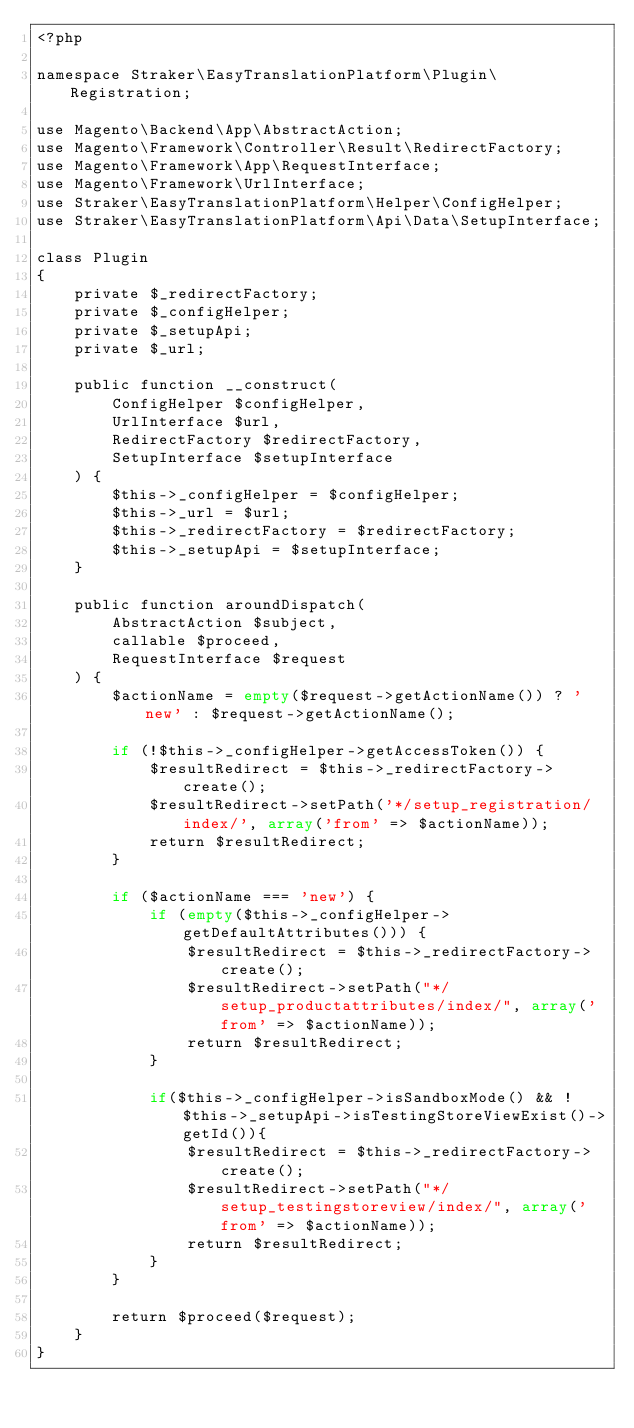<code> <loc_0><loc_0><loc_500><loc_500><_PHP_><?php

namespace Straker\EasyTranslationPlatform\Plugin\Registration;

use Magento\Backend\App\AbstractAction;
use Magento\Framework\Controller\Result\RedirectFactory;
use Magento\Framework\App\RequestInterface;
use Magento\Framework\UrlInterface;
use Straker\EasyTranslationPlatform\Helper\ConfigHelper;
use Straker\EasyTranslationPlatform\Api\Data\SetupInterface;

class Plugin
{
    private $_redirectFactory;
    private $_configHelper;
    private $_setupApi;
    private $_url;

    public function __construct(
        ConfigHelper $configHelper,
        UrlInterface $url,
        RedirectFactory $redirectFactory,
        SetupInterface $setupInterface
    ) {
        $this->_configHelper = $configHelper;
        $this->_url = $url;
        $this->_redirectFactory = $redirectFactory;
        $this->_setupApi = $setupInterface;
    }

    public function aroundDispatch(
        AbstractAction $subject,
        callable $proceed,
        RequestInterface $request
    ) {
        $actionName = empty($request->getActionName()) ? 'new' : $request->getActionName();

        if (!$this->_configHelper->getAccessToken()) {
            $resultRedirect = $this->_redirectFactory->create();
            $resultRedirect->setPath('*/setup_registration/index/', array('from' => $actionName));
            return $resultRedirect;
        }

        if ($actionName === 'new') {
            if (empty($this->_configHelper->getDefaultAttributes())) {
                $resultRedirect = $this->_redirectFactory->create();
                $resultRedirect->setPath("*/setup_productattributes/index/", array('from' => $actionName));
                return $resultRedirect;
            }

            if($this->_configHelper->isSandboxMode() && !$this->_setupApi->isTestingStoreViewExist()->getId()){
                $resultRedirect = $this->_redirectFactory->create();
                $resultRedirect->setPath("*/setup_testingstoreview/index/", array('from' => $actionName));
                return $resultRedirect;
            }
        }

        return $proceed($request);
    }
}
</code> 